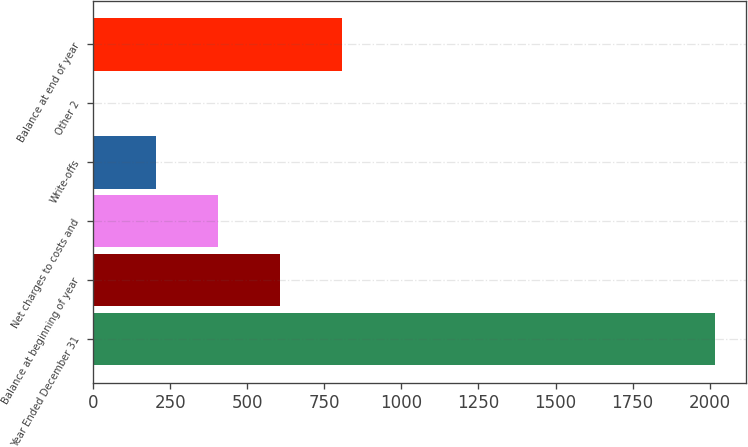Convert chart. <chart><loc_0><loc_0><loc_500><loc_500><bar_chart><fcel>Year Ended December 31<fcel>Balance at beginning of year<fcel>Net charges to costs and<fcel>Write-offs<fcel>Other 2<fcel>Balance at end of year<nl><fcel>2016<fcel>606.2<fcel>404.8<fcel>203.4<fcel>2<fcel>807.6<nl></chart> 